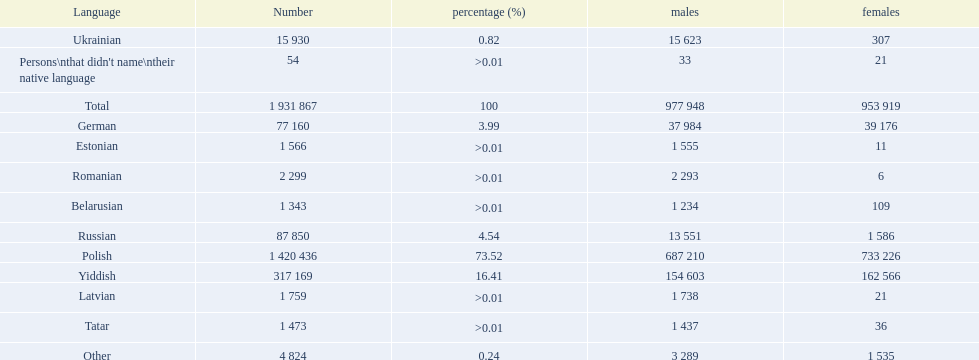What is the highest percentage of speakers other than polish? Yiddish. 